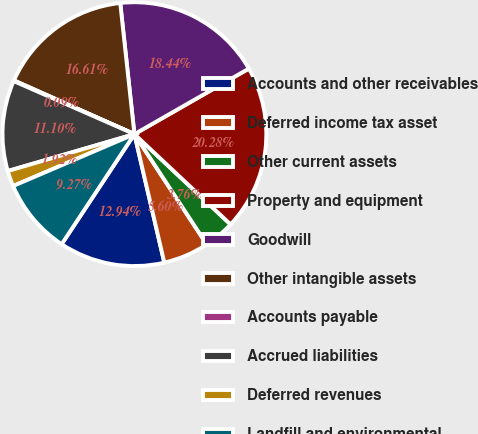<chart> <loc_0><loc_0><loc_500><loc_500><pie_chart><fcel>Accounts and other receivables<fcel>Deferred income tax asset<fcel>Other current assets<fcel>Property and equipment<fcel>Goodwill<fcel>Other intangible assets<fcel>Accounts payable<fcel>Accrued liabilities<fcel>Deferred revenues<fcel>Landfill and environmental<nl><fcel>12.94%<fcel>5.6%<fcel>3.76%<fcel>20.28%<fcel>18.44%<fcel>16.61%<fcel>0.09%<fcel>11.1%<fcel>1.92%<fcel>9.27%<nl></chart> 